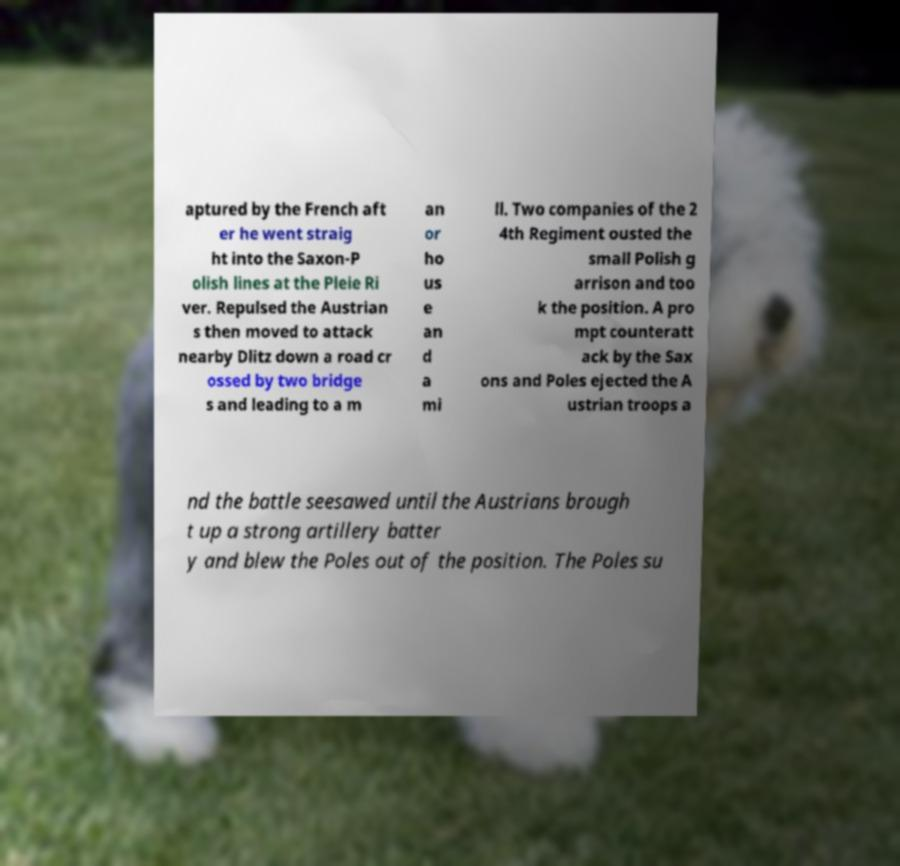Please identify and transcribe the text found in this image. aptured by the French aft er he went straig ht into the Saxon-P olish lines at the Pleie Ri ver. Repulsed the Austrian s then moved to attack nearby Dlitz down a road cr ossed by two bridge s and leading to a m an or ho us e an d a mi ll. Two companies of the 2 4th Regiment ousted the small Polish g arrison and too k the position. A pro mpt counteratt ack by the Sax ons and Poles ejected the A ustrian troops a nd the battle seesawed until the Austrians brough t up a strong artillery batter y and blew the Poles out of the position. The Poles su 